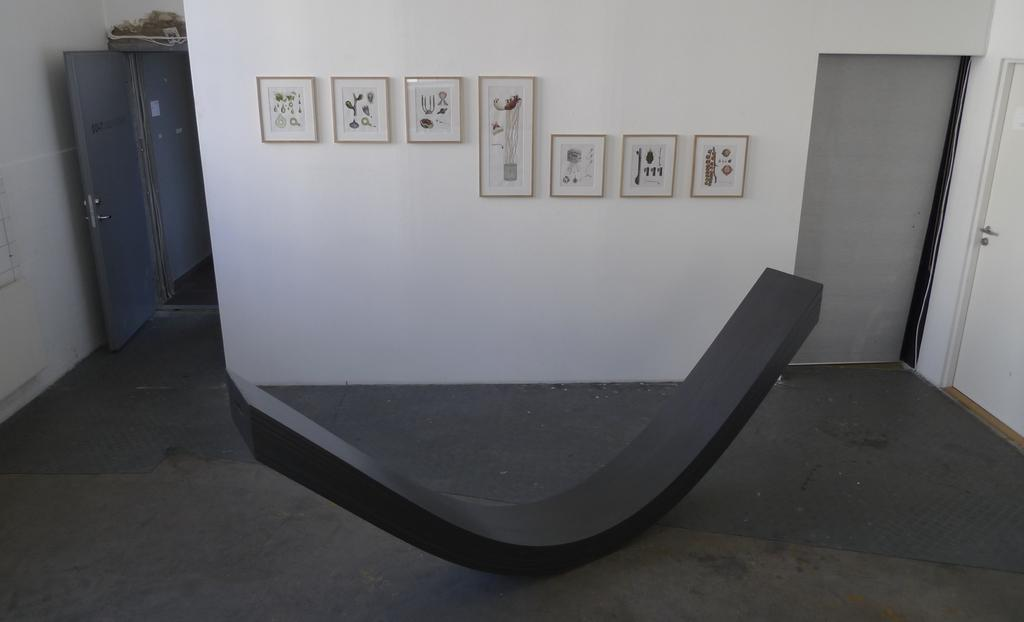What is the color scheme of the image? The image is black and white. What type of subject can be seen in the image? There is an architectural structure in the image. What is one feature of the architectural structure? There is a wall in the image. What is attached to the wall? There are photo frames on the wall. How can one enter or exit the architectural structure? There is a door in the image. Can you hear the sound of thunder in the image? There is no sound present in the image, and therefore no thunder can be heard. How many rabbits are visible in the image? There are no rabbits present in the image. 